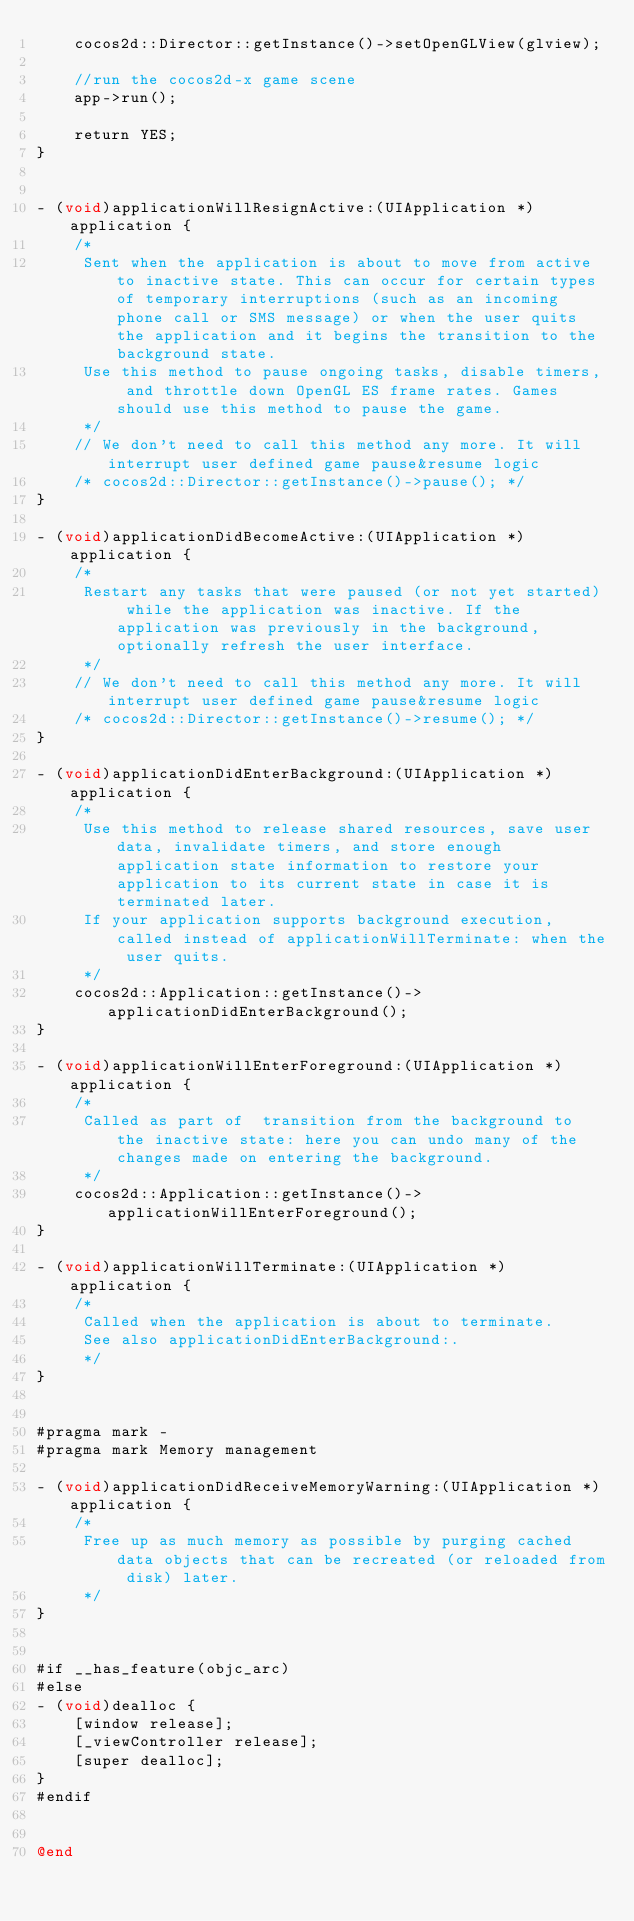Convert code to text. <code><loc_0><loc_0><loc_500><loc_500><_ObjectiveC_>    cocos2d::Director::getInstance()->setOpenGLView(glview);
    
    //run the cocos2d-x game scene
    app->run();

    return YES;
}


- (void)applicationWillResignActive:(UIApplication *)application {
    /*
     Sent when the application is about to move from active to inactive state. This can occur for certain types of temporary interruptions (such as an incoming phone call or SMS message) or when the user quits the application and it begins the transition to the background state.
     Use this method to pause ongoing tasks, disable timers, and throttle down OpenGL ES frame rates. Games should use this method to pause the game.
     */
    // We don't need to call this method any more. It will interrupt user defined game pause&resume logic
    /* cocos2d::Director::getInstance()->pause(); */
}

- (void)applicationDidBecomeActive:(UIApplication *)application {
    /*
     Restart any tasks that were paused (or not yet started) while the application was inactive. If the application was previously in the background, optionally refresh the user interface.
     */
    // We don't need to call this method any more. It will interrupt user defined game pause&resume logic
    /* cocos2d::Director::getInstance()->resume(); */
}

- (void)applicationDidEnterBackground:(UIApplication *)application {
    /*
     Use this method to release shared resources, save user data, invalidate timers, and store enough application state information to restore your application to its current state in case it is terminated later. 
     If your application supports background execution, called instead of applicationWillTerminate: when the user quits.
     */
    cocos2d::Application::getInstance()->applicationDidEnterBackground();
}

- (void)applicationWillEnterForeground:(UIApplication *)application {
    /*
     Called as part of  transition from the background to the inactive state: here you can undo many of the changes made on entering the background.
     */
    cocos2d::Application::getInstance()->applicationWillEnterForeground();
}

- (void)applicationWillTerminate:(UIApplication *)application {
    /*
     Called when the application is about to terminate.
     See also applicationDidEnterBackground:.
     */
}


#pragma mark -
#pragma mark Memory management

- (void)applicationDidReceiveMemoryWarning:(UIApplication *)application {
    /*
     Free up as much memory as possible by purging cached data objects that can be recreated (or reloaded from disk) later.
     */
}


#if __has_feature(objc_arc)
#else
- (void)dealloc {
    [window release];
    [_viewController release];
    [super dealloc];
}
#endif


@end
</code> 